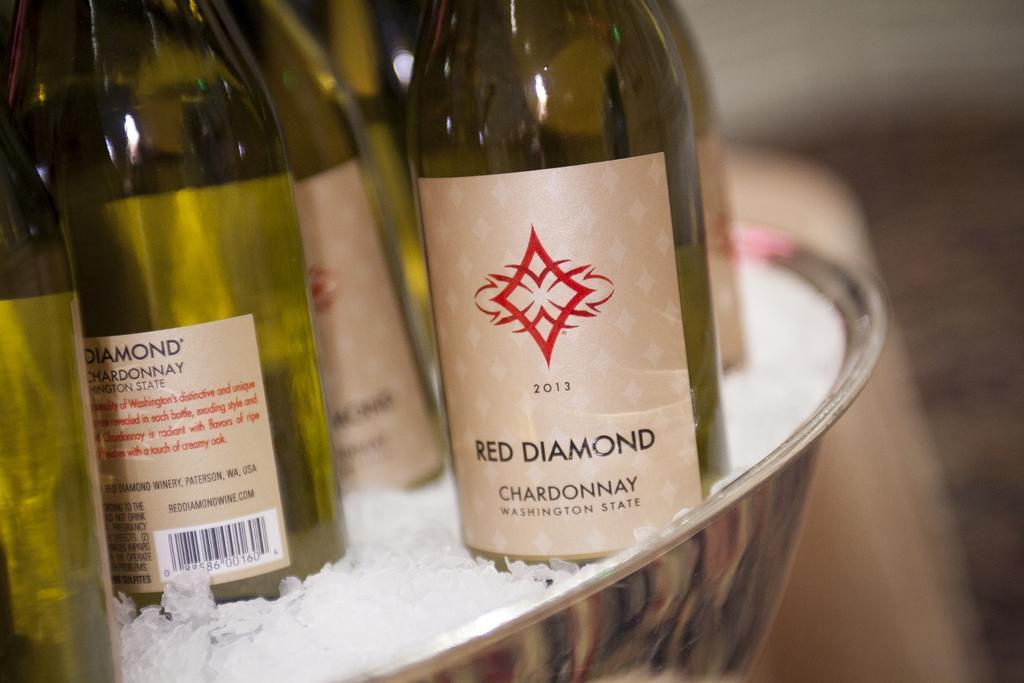How would you summarize this image in a sentence or two? In the foreground, I can see liquor bottles in a bowl in which I can see ice. The background is not clear. This picture might be taken in a hotel. 